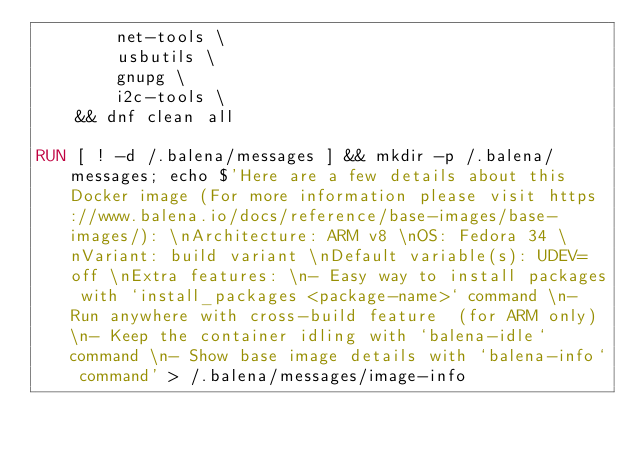<code> <loc_0><loc_0><loc_500><loc_500><_Dockerfile_>		net-tools \
		usbutils \
		gnupg \
		i2c-tools \
	&& dnf clean all

RUN [ ! -d /.balena/messages ] && mkdir -p /.balena/messages; echo $'Here are a few details about this Docker image (For more information please visit https://www.balena.io/docs/reference/base-images/base-images/): \nArchitecture: ARM v8 \nOS: Fedora 34 \nVariant: build variant \nDefault variable(s): UDEV=off \nExtra features: \n- Easy way to install packages with `install_packages <package-name>` command \n- Run anywhere with cross-build feature  (for ARM only) \n- Keep the container idling with `balena-idle` command \n- Show base image details with `balena-info` command' > /.balena/messages/image-info</code> 